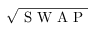Convert formula to latex. <formula><loc_0><loc_0><loc_500><loc_500>\sqrt { S W A P }</formula> 